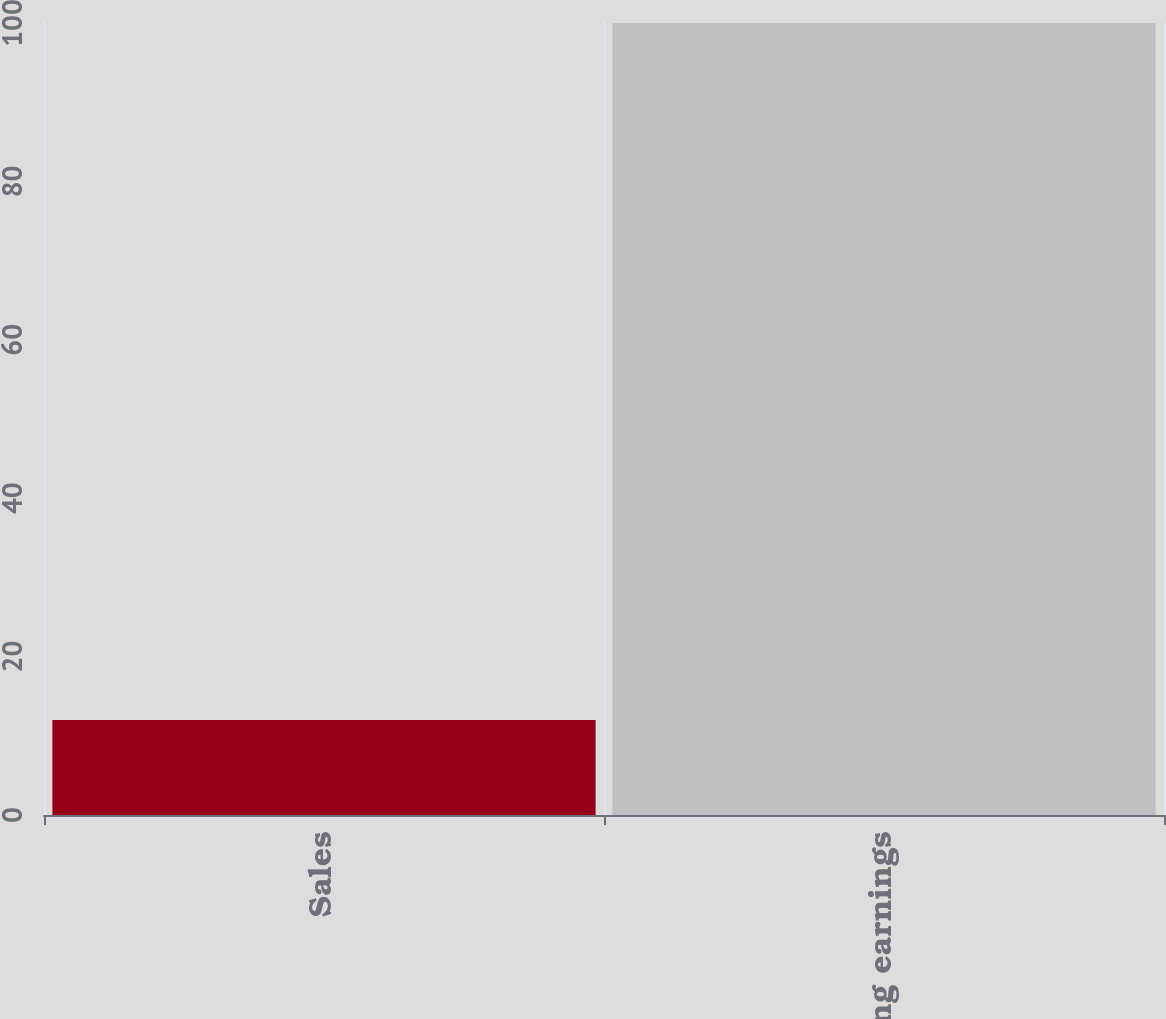Convert chart to OTSL. <chart><loc_0><loc_0><loc_500><loc_500><bar_chart><fcel>Sales<fcel>Operating earnings<nl><fcel>12<fcel>100<nl></chart> 